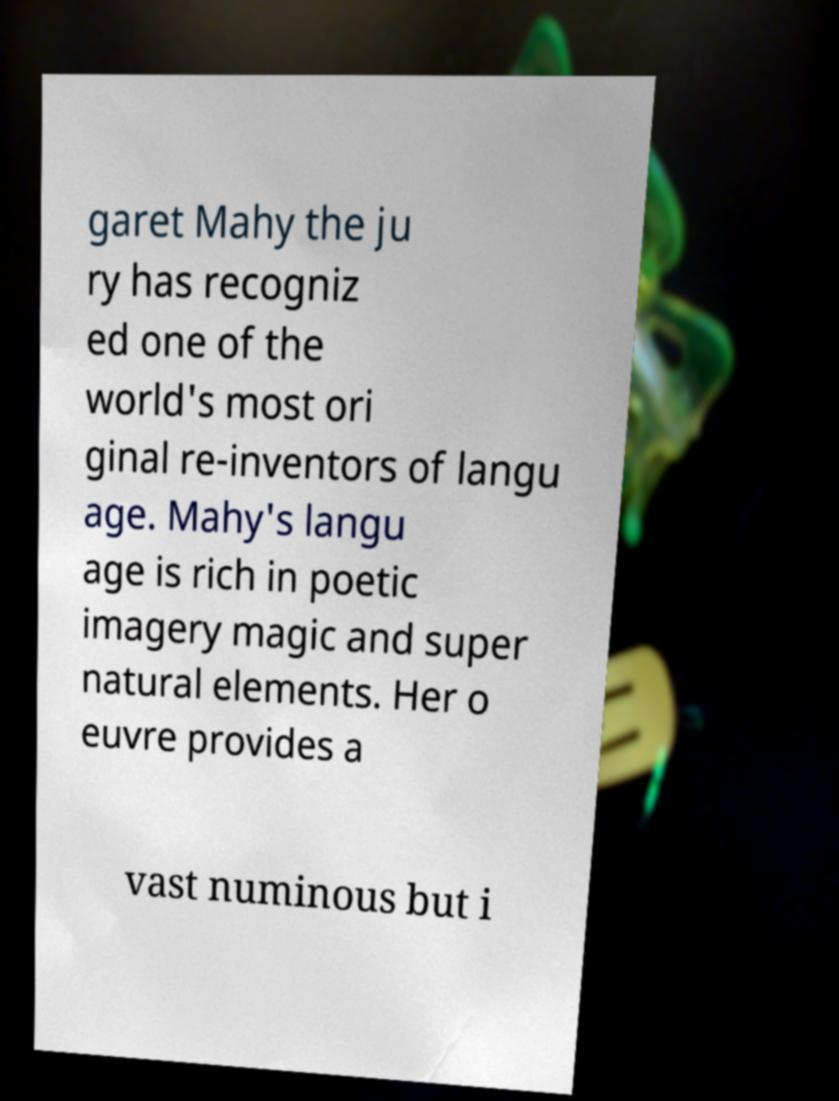Could you assist in decoding the text presented in this image and type it out clearly? garet Mahy the ju ry has recogniz ed one of the world's most ori ginal re-inventors of langu age. Mahy's langu age is rich in poetic imagery magic and super natural elements. Her o euvre provides a vast numinous but i 